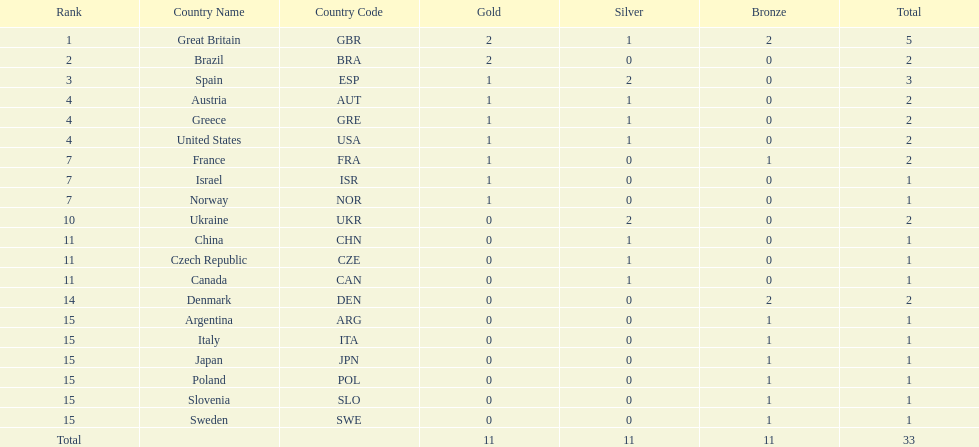Which nation was the only one to receive 3 medals? Spain (ESP). 